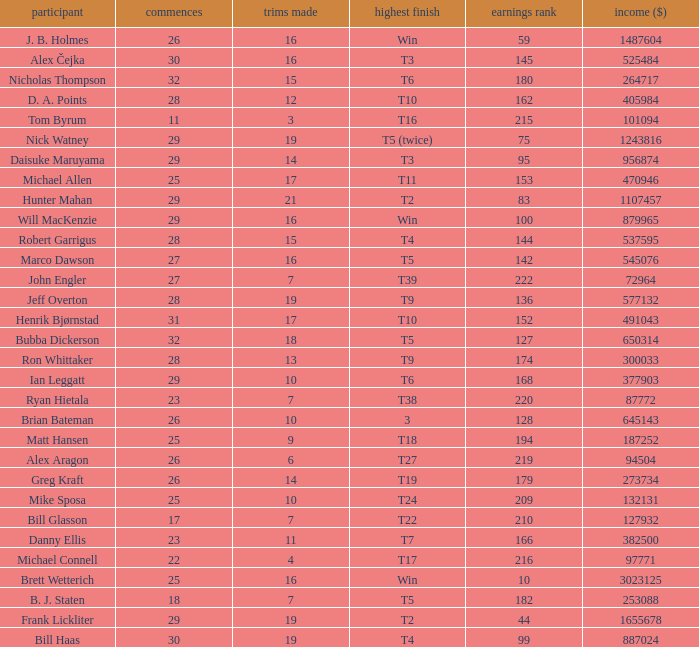What is the minimum money list rank for the players having a best finish of T9? 136.0. 